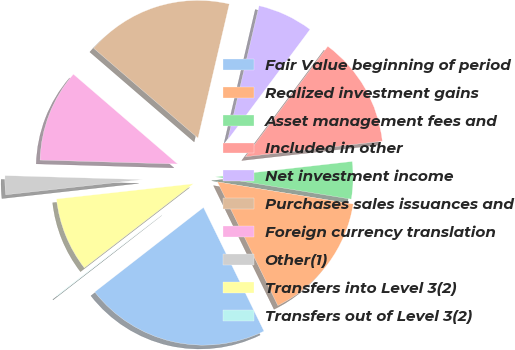Convert chart. <chart><loc_0><loc_0><loc_500><loc_500><pie_chart><fcel>Fair Value beginning of period<fcel>Realized investment gains<fcel>Asset management fees and<fcel>Included in other<fcel>Net investment income<fcel>Purchases sales issuances and<fcel>Foreign currency translation<fcel>Other(1)<fcel>Transfers into Level 3(2)<fcel>Transfers out of Level 3(2)<nl><fcel>21.73%<fcel>15.18%<fcel>4.38%<fcel>13.02%<fcel>6.54%<fcel>17.34%<fcel>10.86%<fcel>2.22%<fcel>8.7%<fcel>0.06%<nl></chart> 